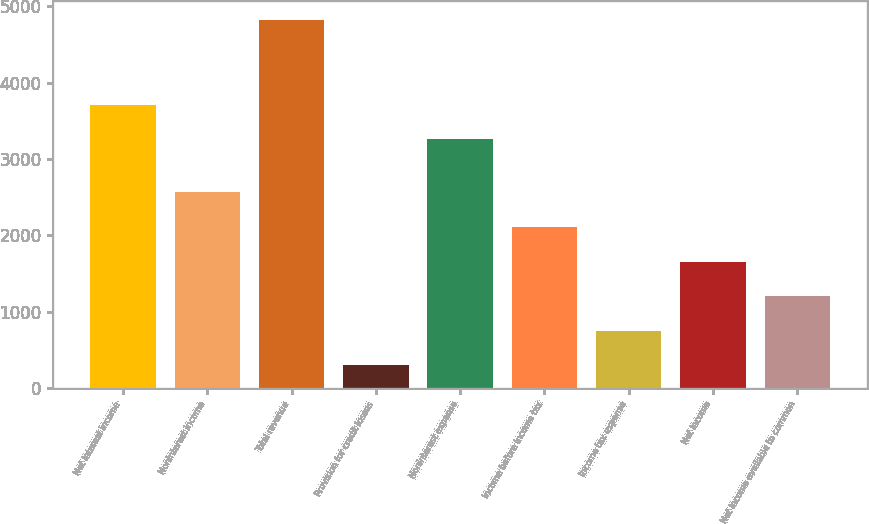Convert chart to OTSL. <chart><loc_0><loc_0><loc_500><loc_500><bar_chart><fcel>Net interest income<fcel>Noninterest income<fcel>Total revenue<fcel>Provision for credit losses<fcel>Noninterest expense<fcel>Income before income tax<fcel>Income tax expense<fcel>Net income<fcel>Net income available to common<nl><fcel>3711.2<fcel>2563<fcel>4824<fcel>302<fcel>3259<fcel>2110.8<fcel>754.2<fcel>1658.6<fcel>1206.4<nl></chart> 